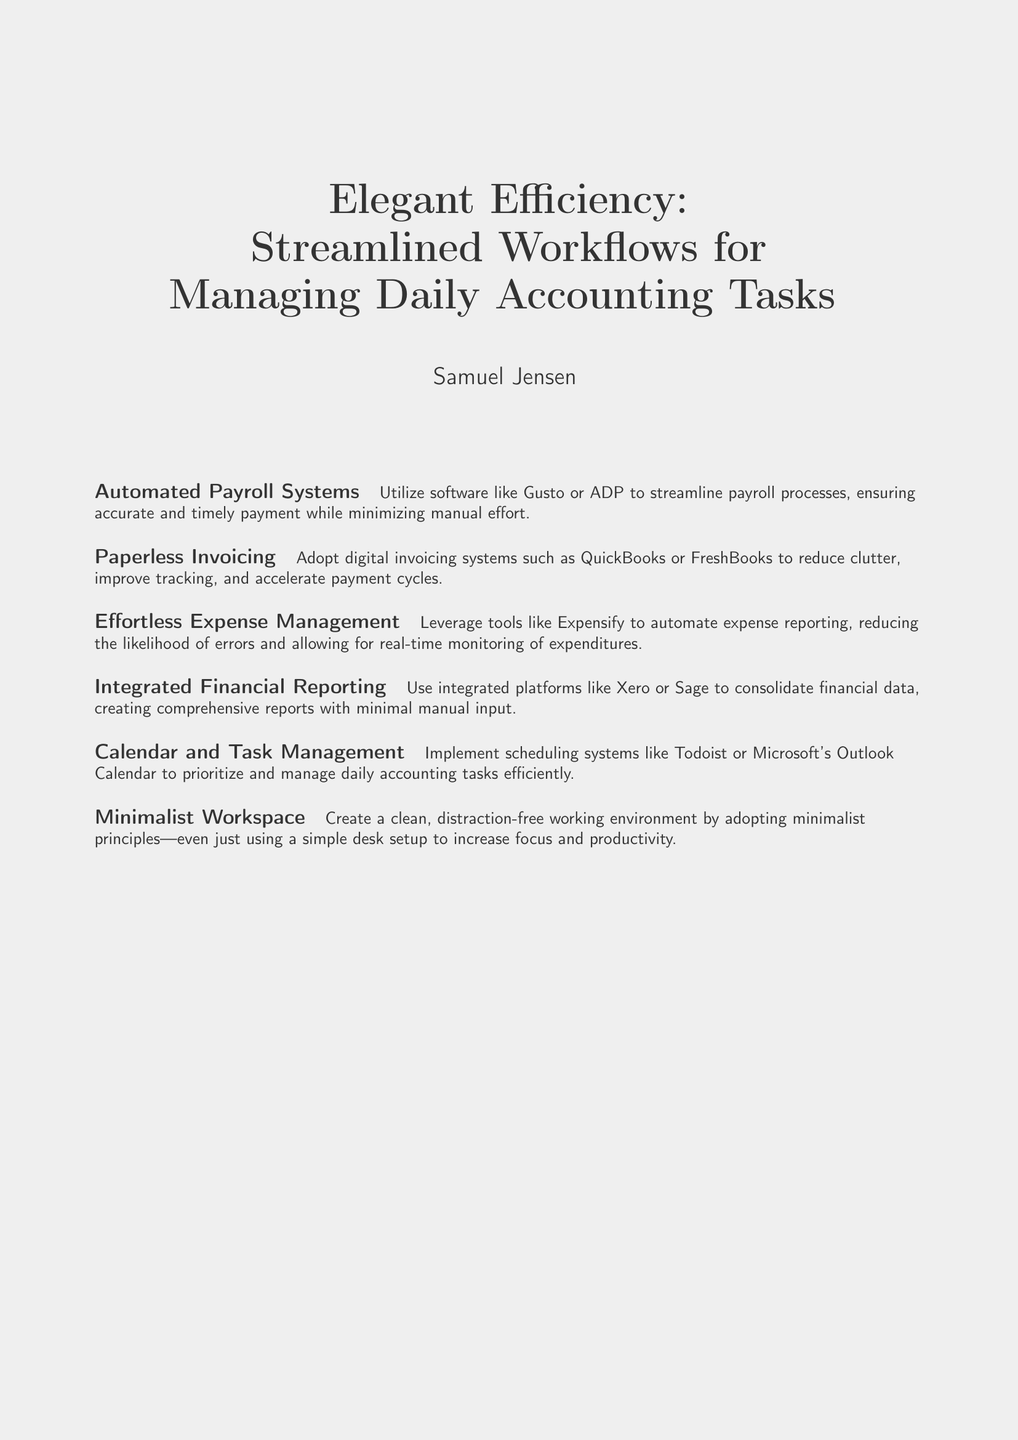What is the title of the book? The title is the main focus of the cover, prominently displayed.
Answer: Elegant Efficiency: Streamlined Workflows for Managing Daily Accounting Tasks Who is the author of the book? The author's name is listed just below the title.
Answer: Samuel Jensen What is one of the topics covered in the book? The book includes several subsections, each addressing a specific workflow improvement.
Answer: Automated Payroll Systems What is a tool suggested for paperless invoicing? The document mentions specific tools in the subsections related to improving accounting tasks.
Answer: QuickBooks What is the benefit of using integrated financial reporting? The document describes the purpose and advantages of specific financial management systems.
Answer: Consolidation of financial data What is recommended for calendar and task management? The book suggests tools for efficient daily task management in accounting.
Answer: Todoist What principle is suggested for creating a workspace? The document discusses a workspace approach that aligns with the book's minimalist theme.
Answer: Minimalist principles Name a software that can automate expense reporting. The book discusses automation tools and mentions specific software for managing expenses.
Answer: Expensify 